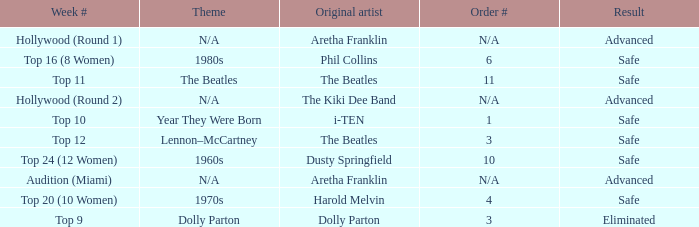What is the week number that has Dolly Parton as the theme? Top 9. 